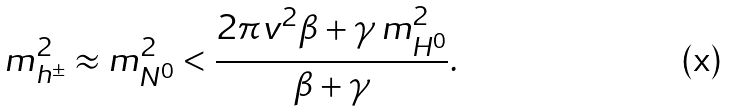Convert formula to latex. <formula><loc_0><loc_0><loc_500><loc_500>m _ { h ^ { \pm } } ^ { 2 } \approx m _ { N ^ { 0 } } ^ { 2 } < \frac { 2 \pi v ^ { 2 } \beta + \gamma \, m _ { H ^ { 0 } } ^ { 2 } } { \beta + \gamma } .</formula> 